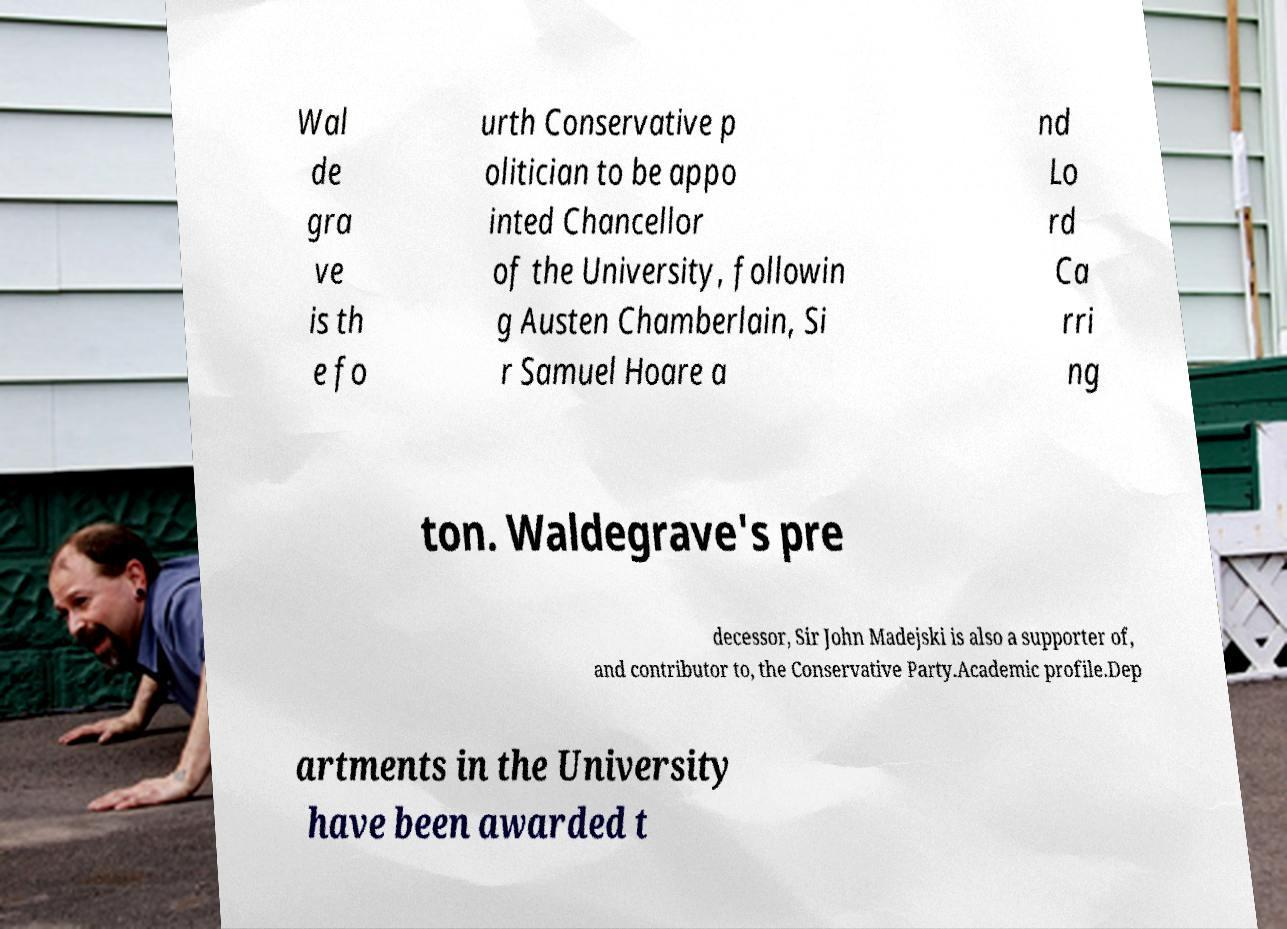Can you accurately transcribe the text from the provided image for me? Wal de gra ve is th e fo urth Conservative p olitician to be appo inted Chancellor of the University, followin g Austen Chamberlain, Si r Samuel Hoare a nd Lo rd Ca rri ng ton. Waldegrave's pre decessor, Sir John Madejski is also a supporter of, and contributor to, the Conservative Party.Academic profile.Dep artments in the University have been awarded t 